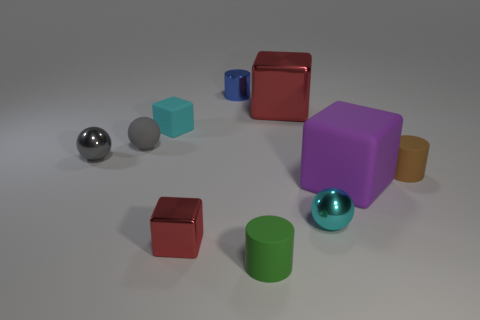Considering the lighting and shadows, what time of day does it seem to be, or what type of lighting is used? The image appears to be artificially lit rather than depicting a natural time of day, with the shadows and highlights indicating the presence of a controlled, diffused light source, likely situated above the objects to create soft and even illumination. 